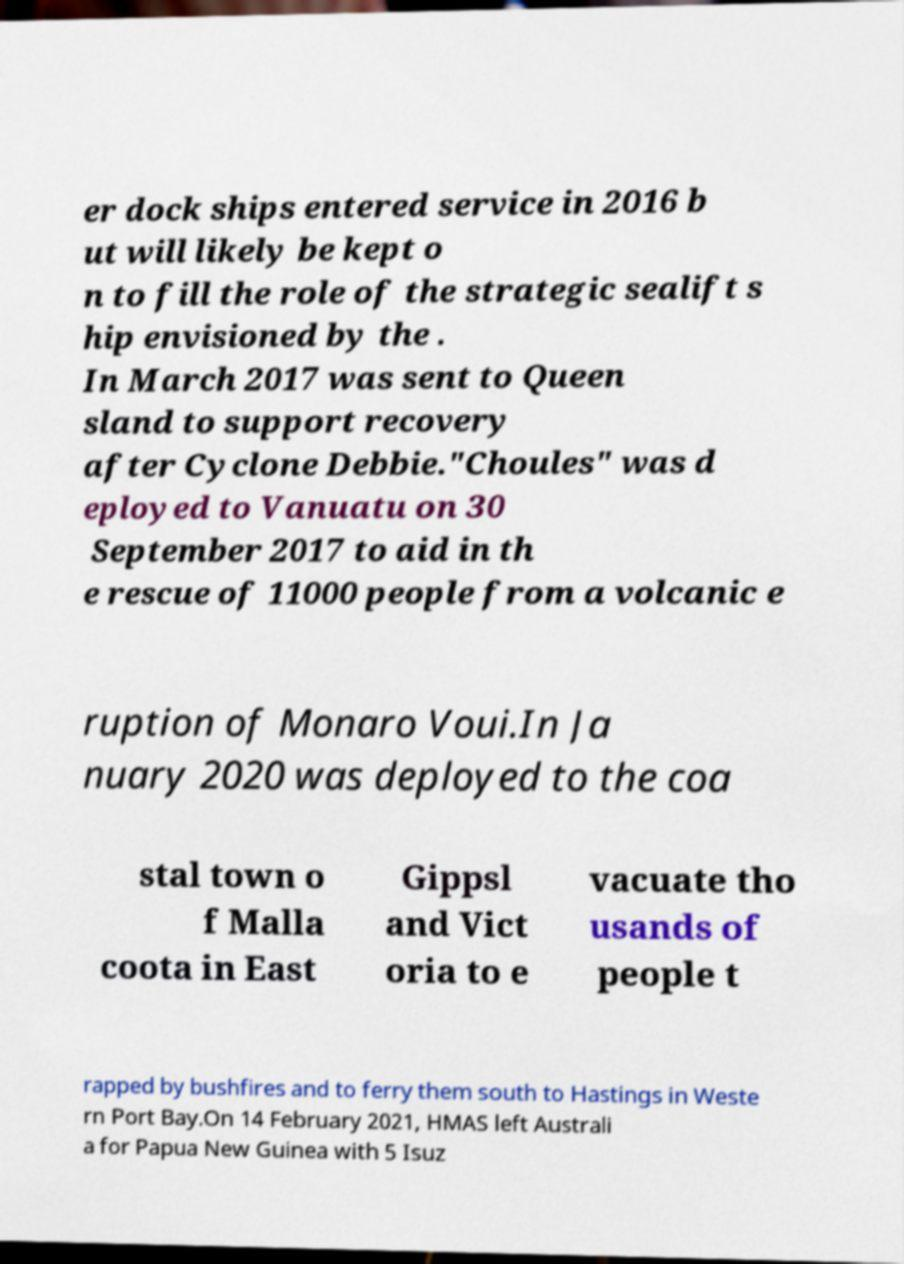For documentation purposes, I need the text within this image transcribed. Could you provide that? er dock ships entered service in 2016 b ut will likely be kept o n to fill the role of the strategic sealift s hip envisioned by the . In March 2017 was sent to Queen sland to support recovery after Cyclone Debbie."Choules" was d eployed to Vanuatu on 30 September 2017 to aid in th e rescue of 11000 people from a volcanic e ruption of Monaro Voui.In Ja nuary 2020 was deployed to the coa stal town o f Malla coota in East Gippsl and Vict oria to e vacuate tho usands of people t rapped by bushfires and to ferry them south to Hastings in Weste rn Port Bay.On 14 February 2021, HMAS left Australi a for Papua New Guinea with 5 Isuz 